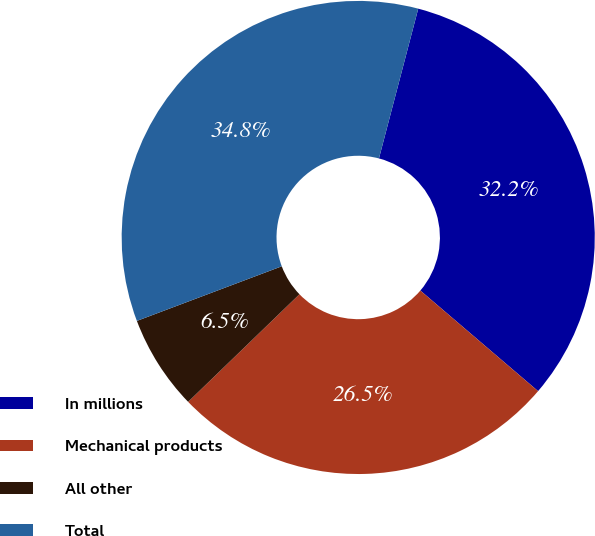<chart> <loc_0><loc_0><loc_500><loc_500><pie_chart><fcel>In millions<fcel>Mechanical products<fcel>All other<fcel>Total<nl><fcel>32.17%<fcel>26.52%<fcel>6.49%<fcel>34.82%<nl></chart> 